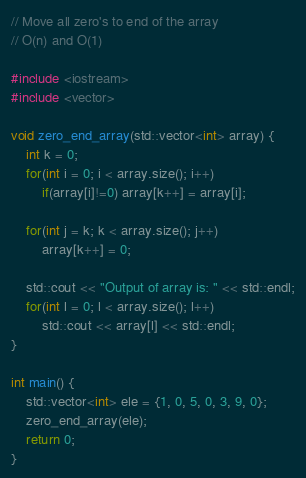Convert code to text. <code><loc_0><loc_0><loc_500><loc_500><_C++_>// Move all zero's to end of the array
// O(n) and O(1)

#include <iostream>
#include <vector>

void zero_end_array(std::vector<int> array) {
	int k = 0;
	for(int i = 0; i < array.size(); i++)
		if(array[i]!=0) array[k++] = array[i];

	for(int j = k; k < array.size(); j++)
		array[k++] = 0;

	std::cout << "Output of array is: " << std::endl;
	for(int l = 0; l < array.size(); l++)
		std::cout << array[l] << std::endl;
}

int main() {
	std::vector<int> ele = {1, 0, 5, 0, 3, 9, 0};
	zero_end_array(ele);
	return 0;
}</code> 